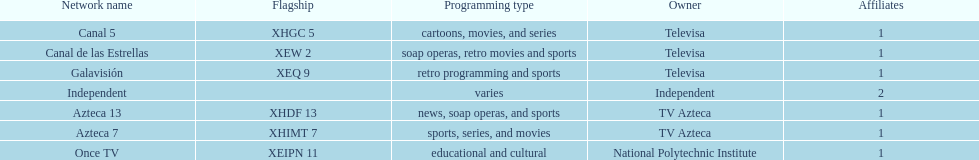Name a station that shows sports but is not televisa. Azteca 7. 